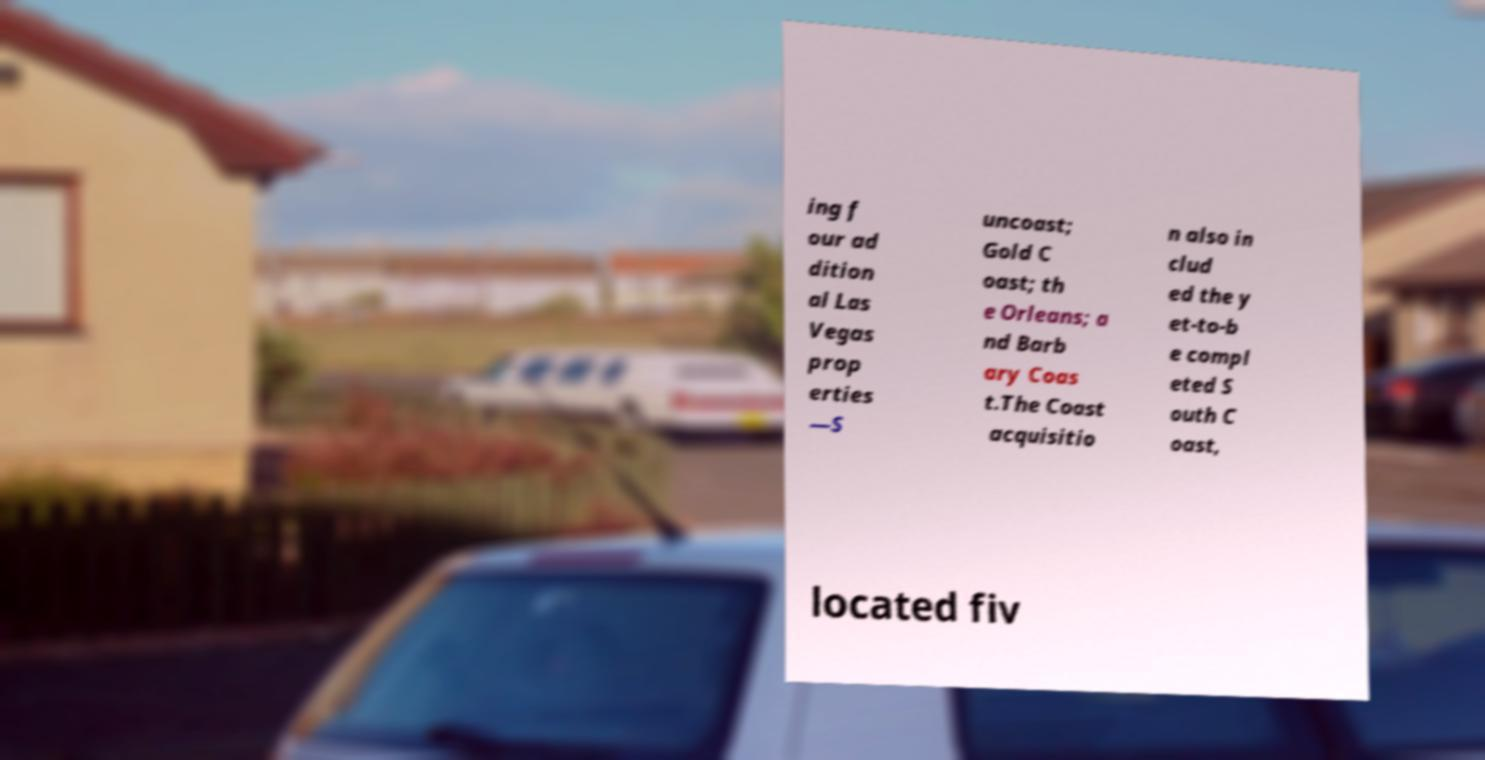Please identify and transcribe the text found in this image. ing f our ad dition al Las Vegas prop erties —S uncoast; Gold C oast; th e Orleans; a nd Barb ary Coas t.The Coast acquisitio n also in clud ed the y et-to-b e compl eted S outh C oast, located fiv 